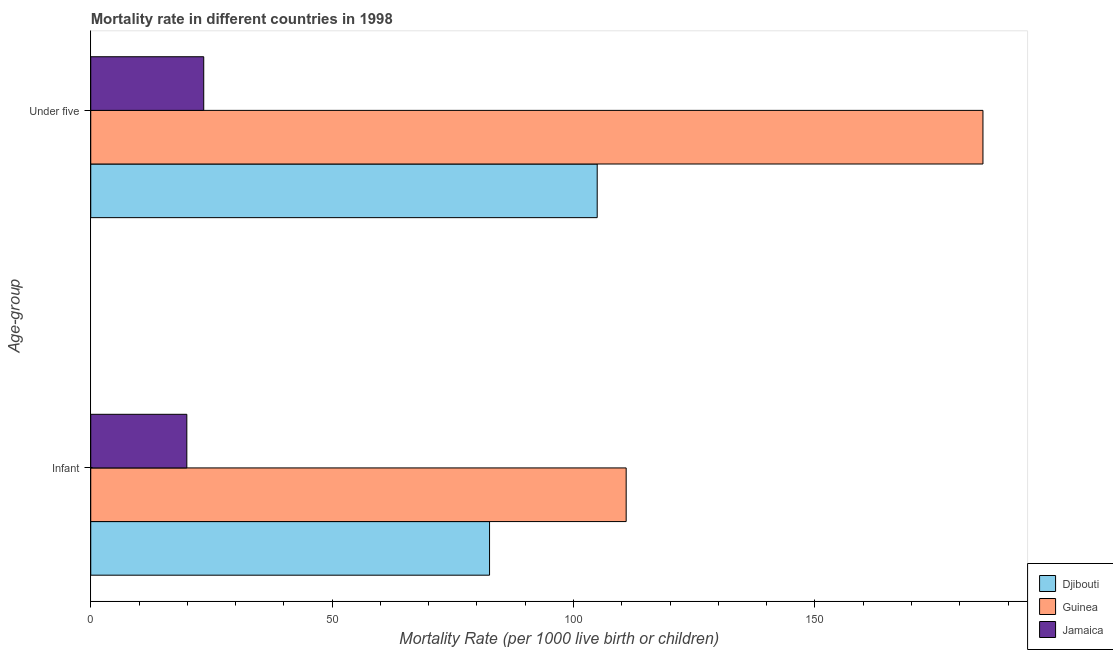How many different coloured bars are there?
Keep it short and to the point. 3. How many bars are there on the 1st tick from the top?
Your answer should be compact. 3. What is the label of the 1st group of bars from the top?
Your answer should be very brief. Under five. What is the under-5 mortality rate in Jamaica?
Your answer should be compact. 23.4. Across all countries, what is the maximum infant mortality rate?
Give a very brief answer. 110.9. Across all countries, what is the minimum under-5 mortality rate?
Provide a succinct answer. 23.4. In which country was the under-5 mortality rate maximum?
Make the answer very short. Guinea. In which country was the infant mortality rate minimum?
Make the answer very short. Jamaica. What is the total infant mortality rate in the graph?
Offer a very short reply. 213.4. What is the difference between the under-5 mortality rate in Guinea and that in Jamaica?
Make the answer very short. 161.4. What is the difference between the infant mortality rate in Djibouti and the under-5 mortality rate in Jamaica?
Give a very brief answer. 59.2. What is the average under-5 mortality rate per country?
Your answer should be compact. 104.37. What is the difference between the under-5 mortality rate and infant mortality rate in Jamaica?
Your response must be concise. 3.5. In how many countries, is the under-5 mortality rate greater than 180 ?
Offer a very short reply. 1. What is the ratio of the under-5 mortality rate in Guinea to that in Djibouti?
Offer a very short reply. 1.76. What does the 1st bar from the top in Infant represents?
Keep it short and to the point. Jamaica. What does the 1st bar from the bottom in Under five represents?
Your answer should be very brief. Djibouti. How many bars are there?
Offer a terse response. 6. Are all the bars in the graph horizontal?
Your answer should be compact. Yes. What is the difference between two consecutive major ticks on the X-axis?
Give a very brief answer. 50. Are the values on the major ticks of X-axis written in scientific E-notation?
Your response must be concise. No. Does the graph contain grids?
Offer a very short reply. No. Where does the legend appear in the graph?
Your response must be concise. Bottom right. How are the legend labels stacked?
Offer a very short reply. Vertical. What is the title of the graph?
Provide a succinct answer. Mortality rate in different countries in 1998. What is the label or title of the X-axis?
Offer a terse response. Mortality Rate (per 1000 live birth or children). What is the label or title of the Y-axis?
Provide a succinct answer. Age-group. What is the Mortality Rate (per 1000 live birth or children) of Djibouti in Infant?
Your response must be concise. 82.6. What is the Mortality Rate (per 1000 live birth or children) in Guinea in Infant?
Keep it short and to the point. 110.9. What is the Mortality Rate (per 1000 live birth or children) of Djibouti in Under five?
Your answer should be very brief. 104.9. What is the Mortality Rate (per 1000 live birth or children) of Guinea in Under five?
Keep it short and to the point. 184.8. What is the Mortality Rate (per 1000 live birth or children) of Jamaica in Under five?
Provide a short and direct response. 23.4. Across all Age-group, what is the maximum Mortality Rate (per 1000 live birth or children) in Djibouti?
Your answer should be very brief. 104.9. Across all Age-group, what is the maximum Mortality Rate (per 1000 live birth or children) of Guinea?
Give a very brief answer. 184.8. Across all Age-group, what is the maximum Mortality Rate (per 1000 live birth or children) of Jamaica?
Ensure brevity in your answer.  23.4. Across all Age-group, what is the minimum Mortality Rate (per 1000 live birth or children) of Djibouti?
Offer a very short reply. 82.6. Across all Age-group, what is the minimum Mortality Rate (per 1000 live birth or children) in Guinea?
Keep it short and to the point. 110.9. What is the total Mortality Rate (per 1000 live birth or children) in Djibouti in the graph?
Give a very brief answer. 187.5. What is the total Mortality Rate (per 1000 live birth or children) of Guinea in the graph?
Offer a very short reply. 295.7. What is the total Mortality Rate (per 1000 live birth or children) of Jamaica in the graph?
Provide a short and direct response. 43.3. What is the difference between the Mortality Rate (per 1000 live birth or children) in Djibouti in Infant and that in Under five?
Provide a short and direct response. -22.3. What is the difference between the Mortality Rate (per 1000 live birth or children) in Guinea in Infant and that in Under five?
Offer a very short reply. -73.9. What is the difference between the Mortality Rate (per 1000 live birth or children) in Djibouti in Infant and the Mortality Rate (per 1000 live birth or children) in Guinea in Under five?
Make the answer very short. -102.2. What is the difference between the Mortality Rate (per 1000 live birth or children) in Djibouti in Infant and the Mortality Rate (per 1000 live birth or children) in Jamaica in Under five?
Ensure brevity in your answer.  59.2. What is the difference between the Mortality Rate (per 1000 live birth or children) of Guinea in Infant and the Mortality Rate (per 1000 live birth or children) of Jamaica in Under five?
Your answer should be very brief. 87.5. What is the average Mortality Rate (per 1000 live birth or children) in Djibouti per Age-group?
Ensure brevity in your answer.  93.75. What is the average Mortality Rate (per 1000 live birth or children) of Guinea per Age-group?
Offer a very short reply. 147.85. What is the average Mortality Rate (per 1000 live birth or children) of Jamaica per Age-group?
Provide a short and direct response. 21.65. What is the difference between the Mortality Rate (per 1000 live birth or children) of Djibouti and Mortality Rate (per 1000 live birth or children) of Guinea in Infant?
Ensure brevity in your answer.  -28.3. What is the difference between the Mortality Rate (per 1000 live birth or children) in Djibouti and Mortality Rate (per 1000 live birth or children) in Jamaica in Infant?
Make the answer very short. 62.7. What is the difference between the Mortality Rate (per 1000 live birth or children) of Guinea and Mortality Rate (per 1000 live birth or children) of Jamaica in Infant?
Your response must be concise. 91. What is the difference between the Mortality Rate (per 1000 live birth or children) of Djibouti and Mortality Rate (per 1000 live birth or children) of Guinea in Under five?
Your answer should be compact. -79.9. What is the difference between the Mortality Rate (per 1000 live birth or children) in Djibouti and Mortality Rate (per 1000 live birth or children) in Jamaica in Under five?
Provide a succinct answer. 81.5. What is the difference between the Mortality Rate (per 1000 live birth or children) in Guinea and Mortality Rate (per 1000 live birth or children) in Jamaica in Under five?
Ensure brevity in your answer.  161.4. What is the ratio of the Mortality Rate (per 1000 live birth or children) of Djibouti in Infant to that in Under five?
Your answer should be compact. 0.79. What is the ratio of the Mortality Rate (per 1000 live birth or children) in Guinea in Infant to that in Under five?
Offer a terse response. 0.6. What is the ratio of the Mortality Rate (per 1000 live birth or children) in Jamaica in Infant to that in Under five?
Offer a terse response. 0.85. What is the difference between the highest and the second highest Mortality Rate (per 1000 live birth or children) of Djibouti?
Give a very brief answer. 22.3. What is the difference between the highest and the second highest Mortality Rate (per 1000 live birth or children) of Guinea?
Ensure brevity in your answer.  73.9. What is the difference between the highest and the lowest Mortality Rate (per 1000 live birth or children) in Djibouti?
Offer a terse response. 22.3. What is the difference between the highest and the lowest Mortality Rate (per 1000 live birth or children) in Guinea?
Your answer should be compact. 73.9. What is the difference between the highest and the lowest Mortality Rate (per 1000 live birth or children) in Jamaica?
Keep it short and to the point. 3.5. 